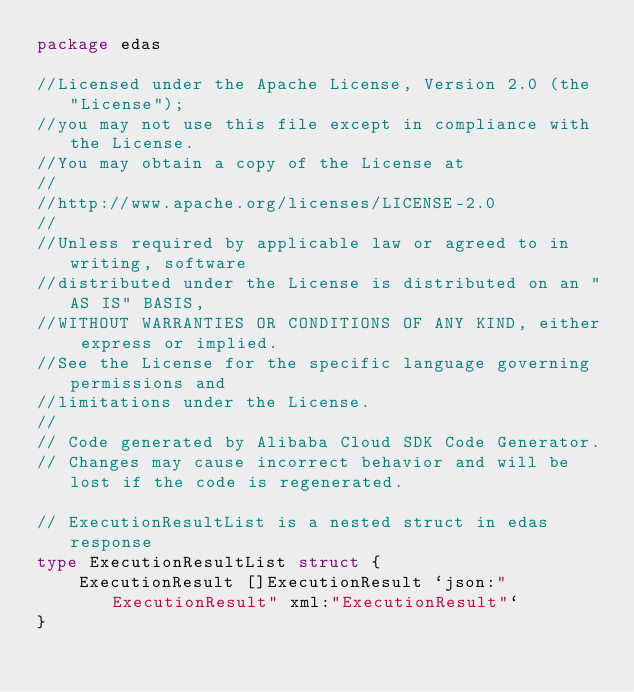<code> <loc_0><loc_0><loc_500><loc_500><_Go_>package edas

//Licensed under the Apache License, Version 2.0 (the "License");
//you may not use this file except in compliance with the License.
//You may obtain a copy of the License at
//
//http://www.apache.org/licenses/LICENSE-2.0
//
//Unless required by applicable law or agreed to in writing, software
//distributed under the License is distributed on an "AS IS" BASIS,
//WITHOUT WARRANTIES OR CONDITIONS OF ANY KIND, either express or implied.
//See the License for the specific language governing permissions and
//limitations under the License.
//
// Code generated by Alibaba Cloud SDK Code Generator.
// Changes may cause incorrect behavior and will be lost if the code is regenerated.

// ExecutionResultList is a nested struct in edas response
type ExecutionResultList struct {
	ExecutionResult []ExecutionResult `json:"ExecutionResult" xml:"ExecutionResult"`
}
</code> 